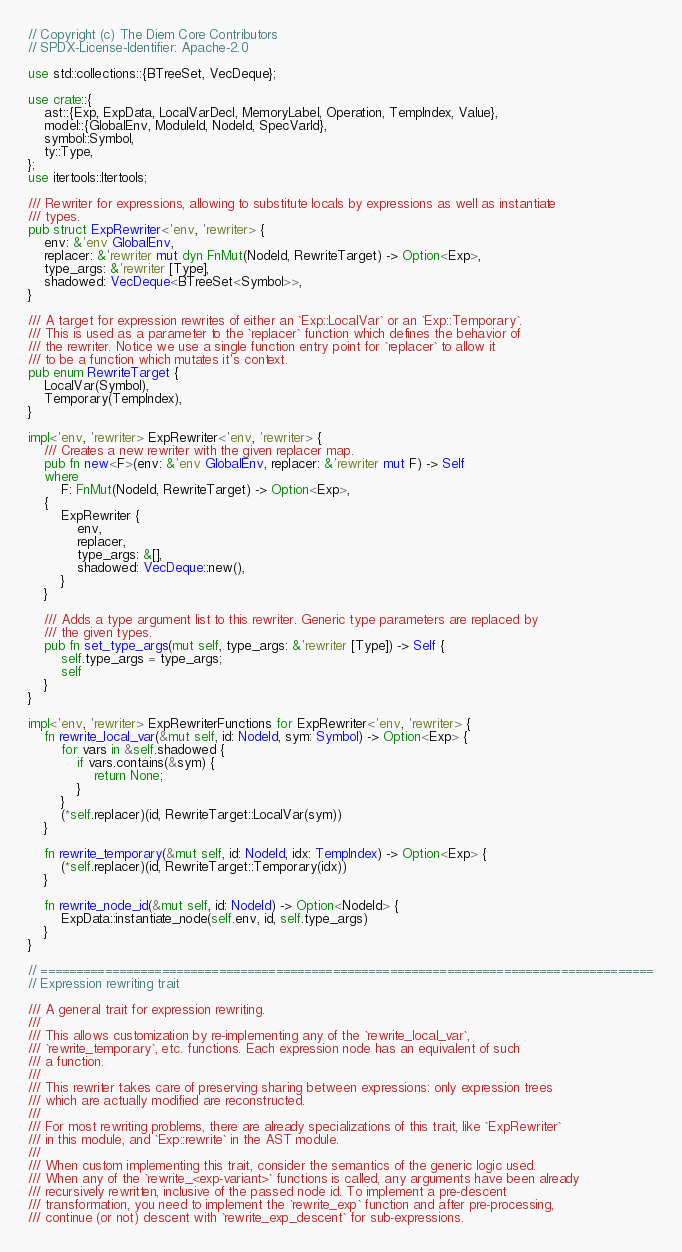<code> <loc_0><loc_0><loc_500><loc_500><_Rust_>// Copyright (c) The Diem Core Contributors
// SPDX-License-Identifier: Apache-2.0

use std::collections::{BTreeSet, VecDeque};

use crate::{
    ast::{Exp, ExpData, LocalVarDecl, MemoryLabel, Operation, TempIndex, Value},
    model::{GlobalEnv, ModuleId, NodeId, SpecVarId},
    symbol::Symbol,
    ty::Type,
};
use itertools::Itertools;

/// Rewriter for expressions, allowing to substitute locals by expressions as well as instantiate
/// types.
pub struct ExpRewriter<'env, 'rewriter> {
    env: &'env GlobalEnv,
    replacer: &'rewriter mut dyn FnMut(NodeId, RewriteTarget) -> Option<Exp>,
    type_args: &'rewriter [Type],
    shadowed: VecDeque<BTreeSet<Symbol>>,
}

/// A target for expression rewrites of either an `Exp::LocalVar` or an `Exp::Temporary`.
/// This is used as a parameter to the `replacer` function which defines the behavior of
/// the rewriter. Notice we use a single function entry point for `replacer` to allow it
/// to be a function which mutates it's context.
pub enum RewriteTarget {
    LocalVar(Symbol),
    Temporary(TempIndex),
}

impl<'env, 'rewriter> ExpRewriter<'env, 'rewriter> {
    /// Creates a new rewriter with the given replacer map.
    pub fn new<F>(env: &'env GlobalEnv, replacer: &'rewriter mut F) -> Self
    where
        F: FnMut(NodeId, RewriteTarget) -> Option<Exp>,
    {
        ExpRewriter {
            env,
            replacer,
            type_args: &[],
            shadowed: VecDeque::new(),
        }
    }

    /// Adds a type argument list to this rewriter. Generic type parameters are replaced by
    /// the given types.
    pub fn set_type_args(mut self, type_args: &'rewriter [Type]) -> Self {
        self.type_args = type_args;
        self
    }
}

impl<'env, 'rewriter> ExpRewriterFunctions for ExpRewriter<'env, 'rewriter> {
    fn rewrite_local_var(&mut self, id: NodeId, sym: Symbol) -> Option<Exp> {
        for vars in &self.shadowed {
            if vars.contains(&sym) {
                return None;
            }
        }
        (*self.replacer)(id, RewriteTarget::LocalVar(sym))
    }

    fn rewrite_temporary(&mut self, id: NodeId, idx: TempIndex) -> Option<Exp> {
        (*self.replacer)(id, RewriteTarget::Temporary(idx))
    }

    fn rewrite_node_id(&mut self, id: NodeId) -> Option<NodeId> {
        ExpData::instantiate_node(self.env, id, self.type_args)
    }
}

// ======================================================================================
// Expression rewriting trait

/// A general trait for expression rewriting.
///
/// This allows customization by re-implementing any of the `rewrite_local_var`,
/// `rewrite_temporary`, etc. functions. Each expression node has an equivalent of such
/// a function.
///
/// This rewriter takes care of preserving sharing between expressions: only expression trees
/// which are actually modified are reconstructed.
///
/// For most rewriting problems, there are already specializations of this trait, like `ExpRewriter`
/// in this module, and `Exp::rewrite` in the AST module.
///
/// When custom implementing this trait, consider the semantics of the generic logic used.
/// When any of the `rewrite_<exp-variant>` functions is called, any arguments have been already
/// recursively rewritten, inclusive of the passed node id. To implement a pre-descent
/// transformation, you need to implement the `rewrite_exp` function and after pre-processing,
/// continue (or not) descent with `rewrite_exp_descent` for sub-expressions.</code> 